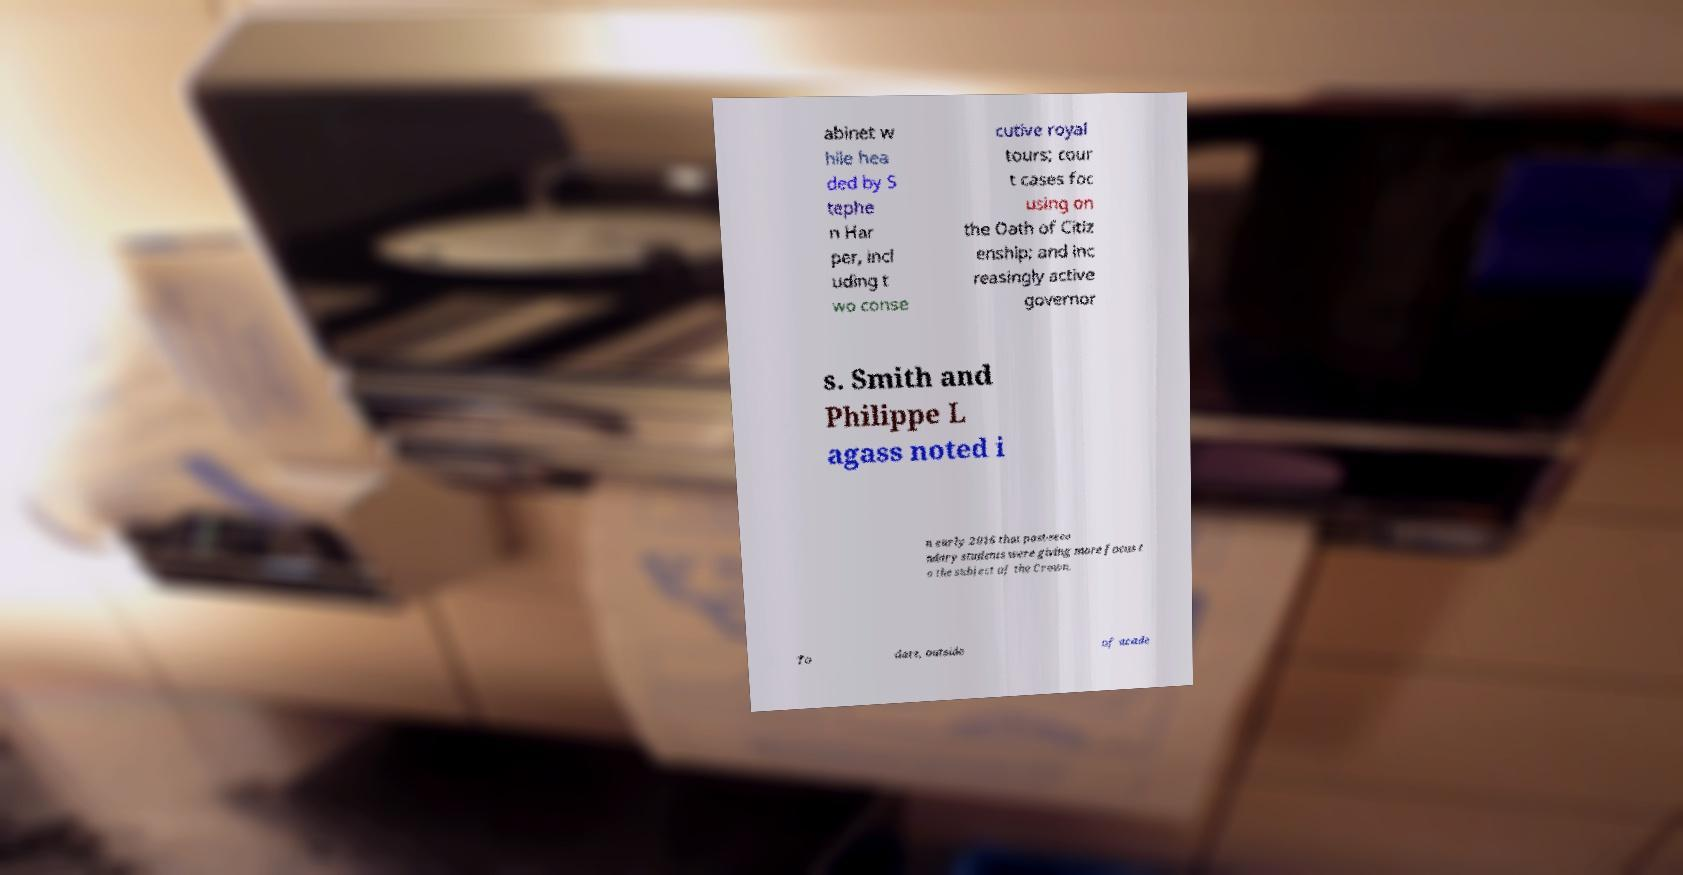Could you assist in decoding the text presented in this image and type it out clearly? abinet w hile hea ded by S tephe n Har per, incl uding t wo conse cutive royal tours; cour t cases foc using on the Oath of Citiz enship; and inc reasingly active governor s. Smith and Philippe L agass noted i n early 2016 that post-seco ndary students were giving more focus t o the subject of the Crown. To date, outside of acade 